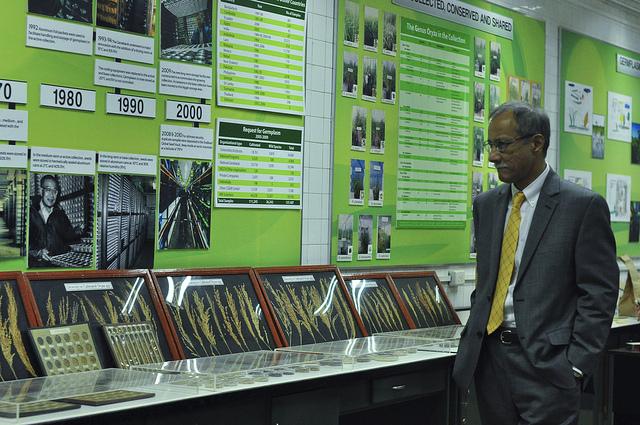How many different centuries are represented on the wall?
Quick response, please. 4. Is the man wearing glasses?
Write a very short answer. Yes. What color is the man's tie?
Answer briefly. Yellow. 